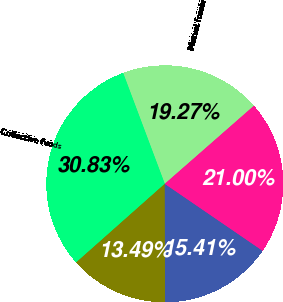Convert chart. <chart><loc_0><loc_0><loc_500><loc_500><pie_chart><fcel>Mutual funds<fcel>Collective funds<fcel>Pension products<fcel>Insurance and other products<fcel>Total<nl><fcel>19.27%<fcel>30.83%<fcel>13.49%<fcel>15.41%<fcel>21.0%<nl></chart> 